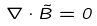Convert formula to latex. <formula><loc_0><loc_0><loc_500><loc_500>\nabla \cdot \vec { B } = 0</formula> 